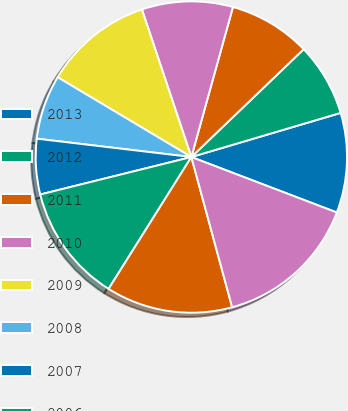<chart> <loc_0><loc_0><loc_500><loc_500><pie_chart><fcel>2013<fcel>2012<fcel>2011<fcel>2010<fcel>2009<fcel>2008<fcel>2007<fcel>2006<fcel>2005<fcel>2004<nl><fcel>10.37%<fcel>7.6%<fcel>8.52%<fcel>9.45%<fcel>11.29%<fcel>6.68%<fcel>5.75%<fcel>12.21%<fcel>13.14%<fcel>14.98%<nl></chart> 